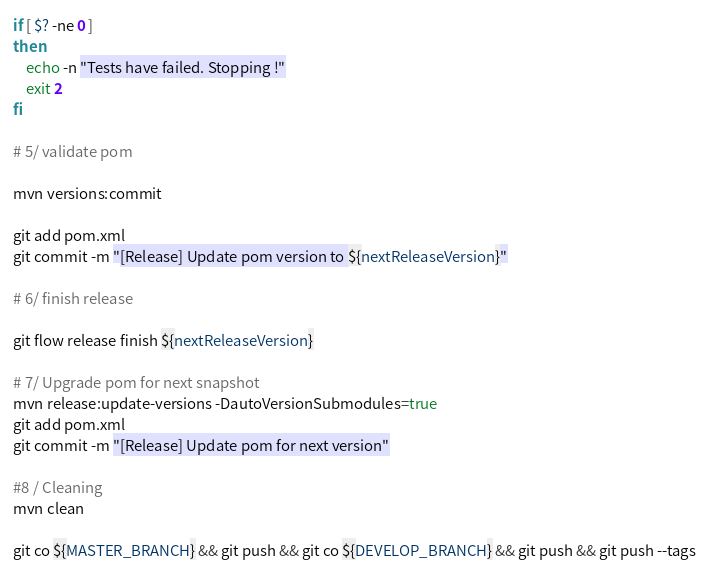<code> <loc_0><loc_0><loc_500><loc_500><_Bash_>if [ $? -ne 0 ] 
then
	echo -n "Tests have failed. Stopping !"
	exit 2
fi

# 5/ validate pom

mvn versions:commit

git add pom.xml
git commit -m "[Release] Update pom version to ${nextReleaseVersion}"

# 6/ finish release

git flow release finish ${nextReleaseVersion}

# 7/ Upgrade pom for next snapshot
mvn release:update-versions -DautoVersionSubmodules=true
git add pom.xml
git commit -m "[Release] Update pom for next version"

#8 / Cleaning
mvn clean

git co ${MASTER_BRANCH} && git push && git co ${DEVELOP_BRANCH} && git push && git push --tags
</code> 